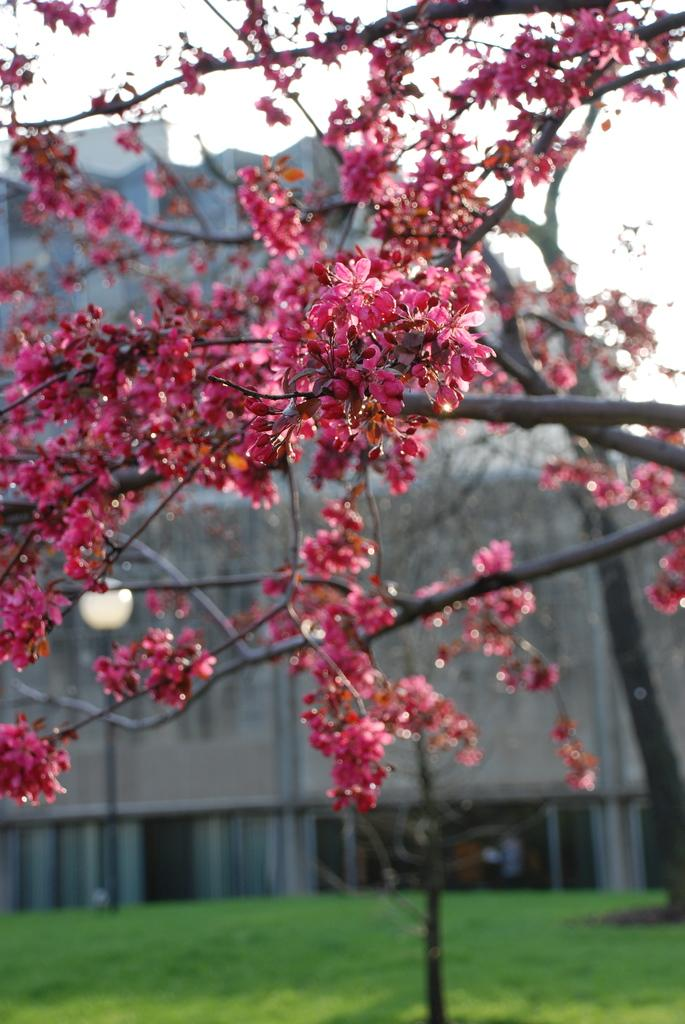What type of tree is in the image? There is a tree with red flowers in the image. What is located behind the tree? There is a building behind the tree. What is in front of the tree? There is grass in front of the tree. Can you see a maid holding a pear in the image? There is no maid or pear present in the image. 